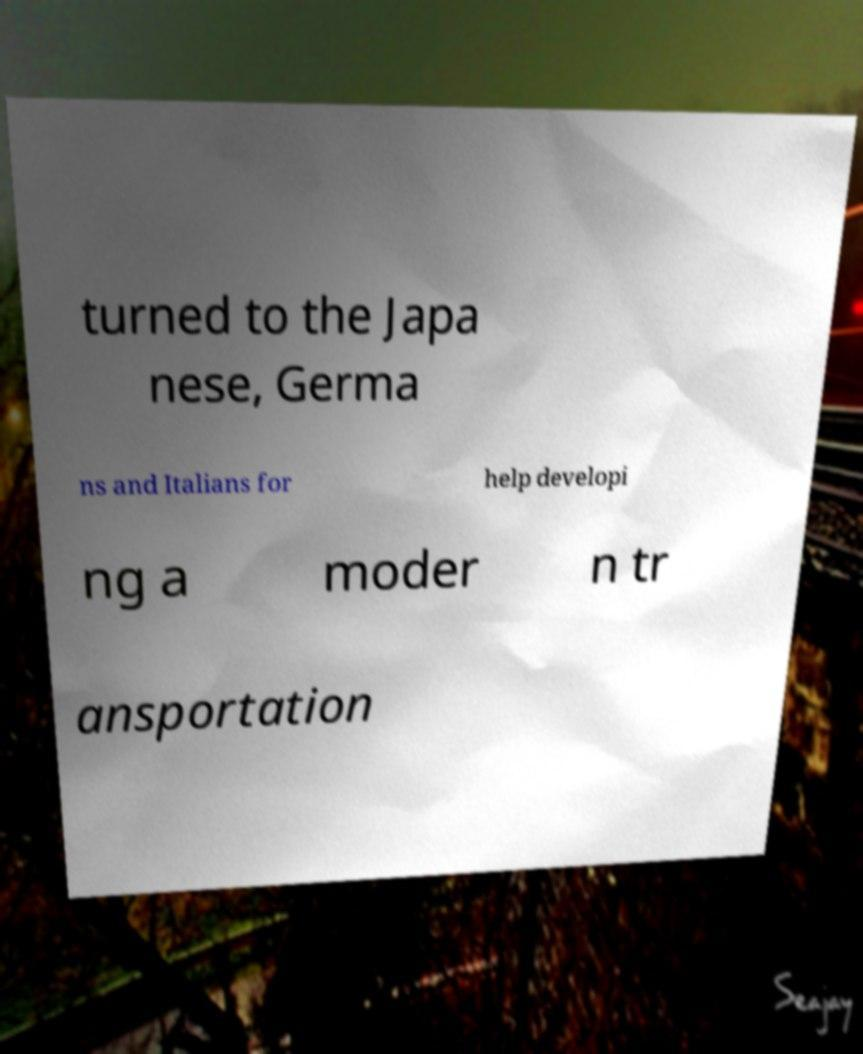Could you extract and type out the text from this image? turned to the Japa nese, Germa ns and Italians for help developi ng a moder n tr ansportation 